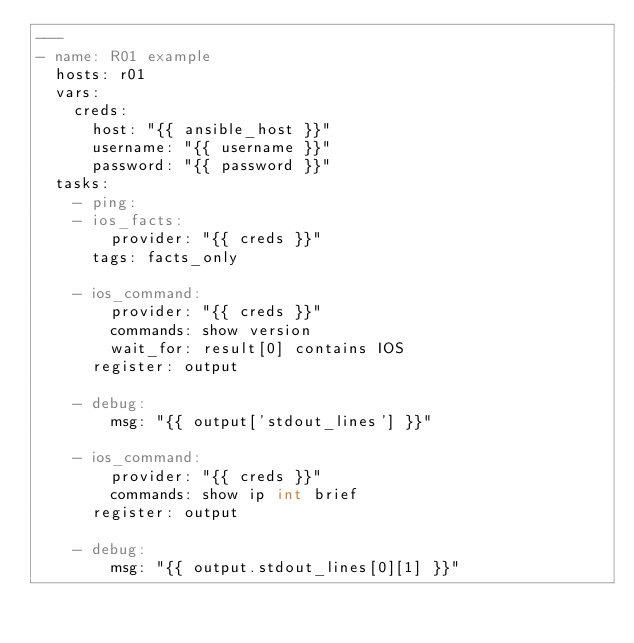<code> <loc_0><loc_0><loc_500><loc_500><_YAML_>---
- name: R01 example
  hosts: r01
  vars:
    creds:
      host: "{{ ansible_host }}"
      username: "{{ username }}"
      password: "{{ password }}"
  tasks:
    - ping:
    - ios_facts:
        provider: "{{ creds }}"
      tags: facts_only

    - ios_command:
        provider: "{{ creds }}"
        commands: show version
        wait_for: result[0] contains IOS
      register: output

    - debug:
        msg: "{{ output['stdout_lines'] }}"

    - ios_command:
        provider: "{{ creds }}"
        commands: show ip int brief
      register: output

    - debug:
        msg: "{{ output.stdout_lines[0][1] }}"
</code> 